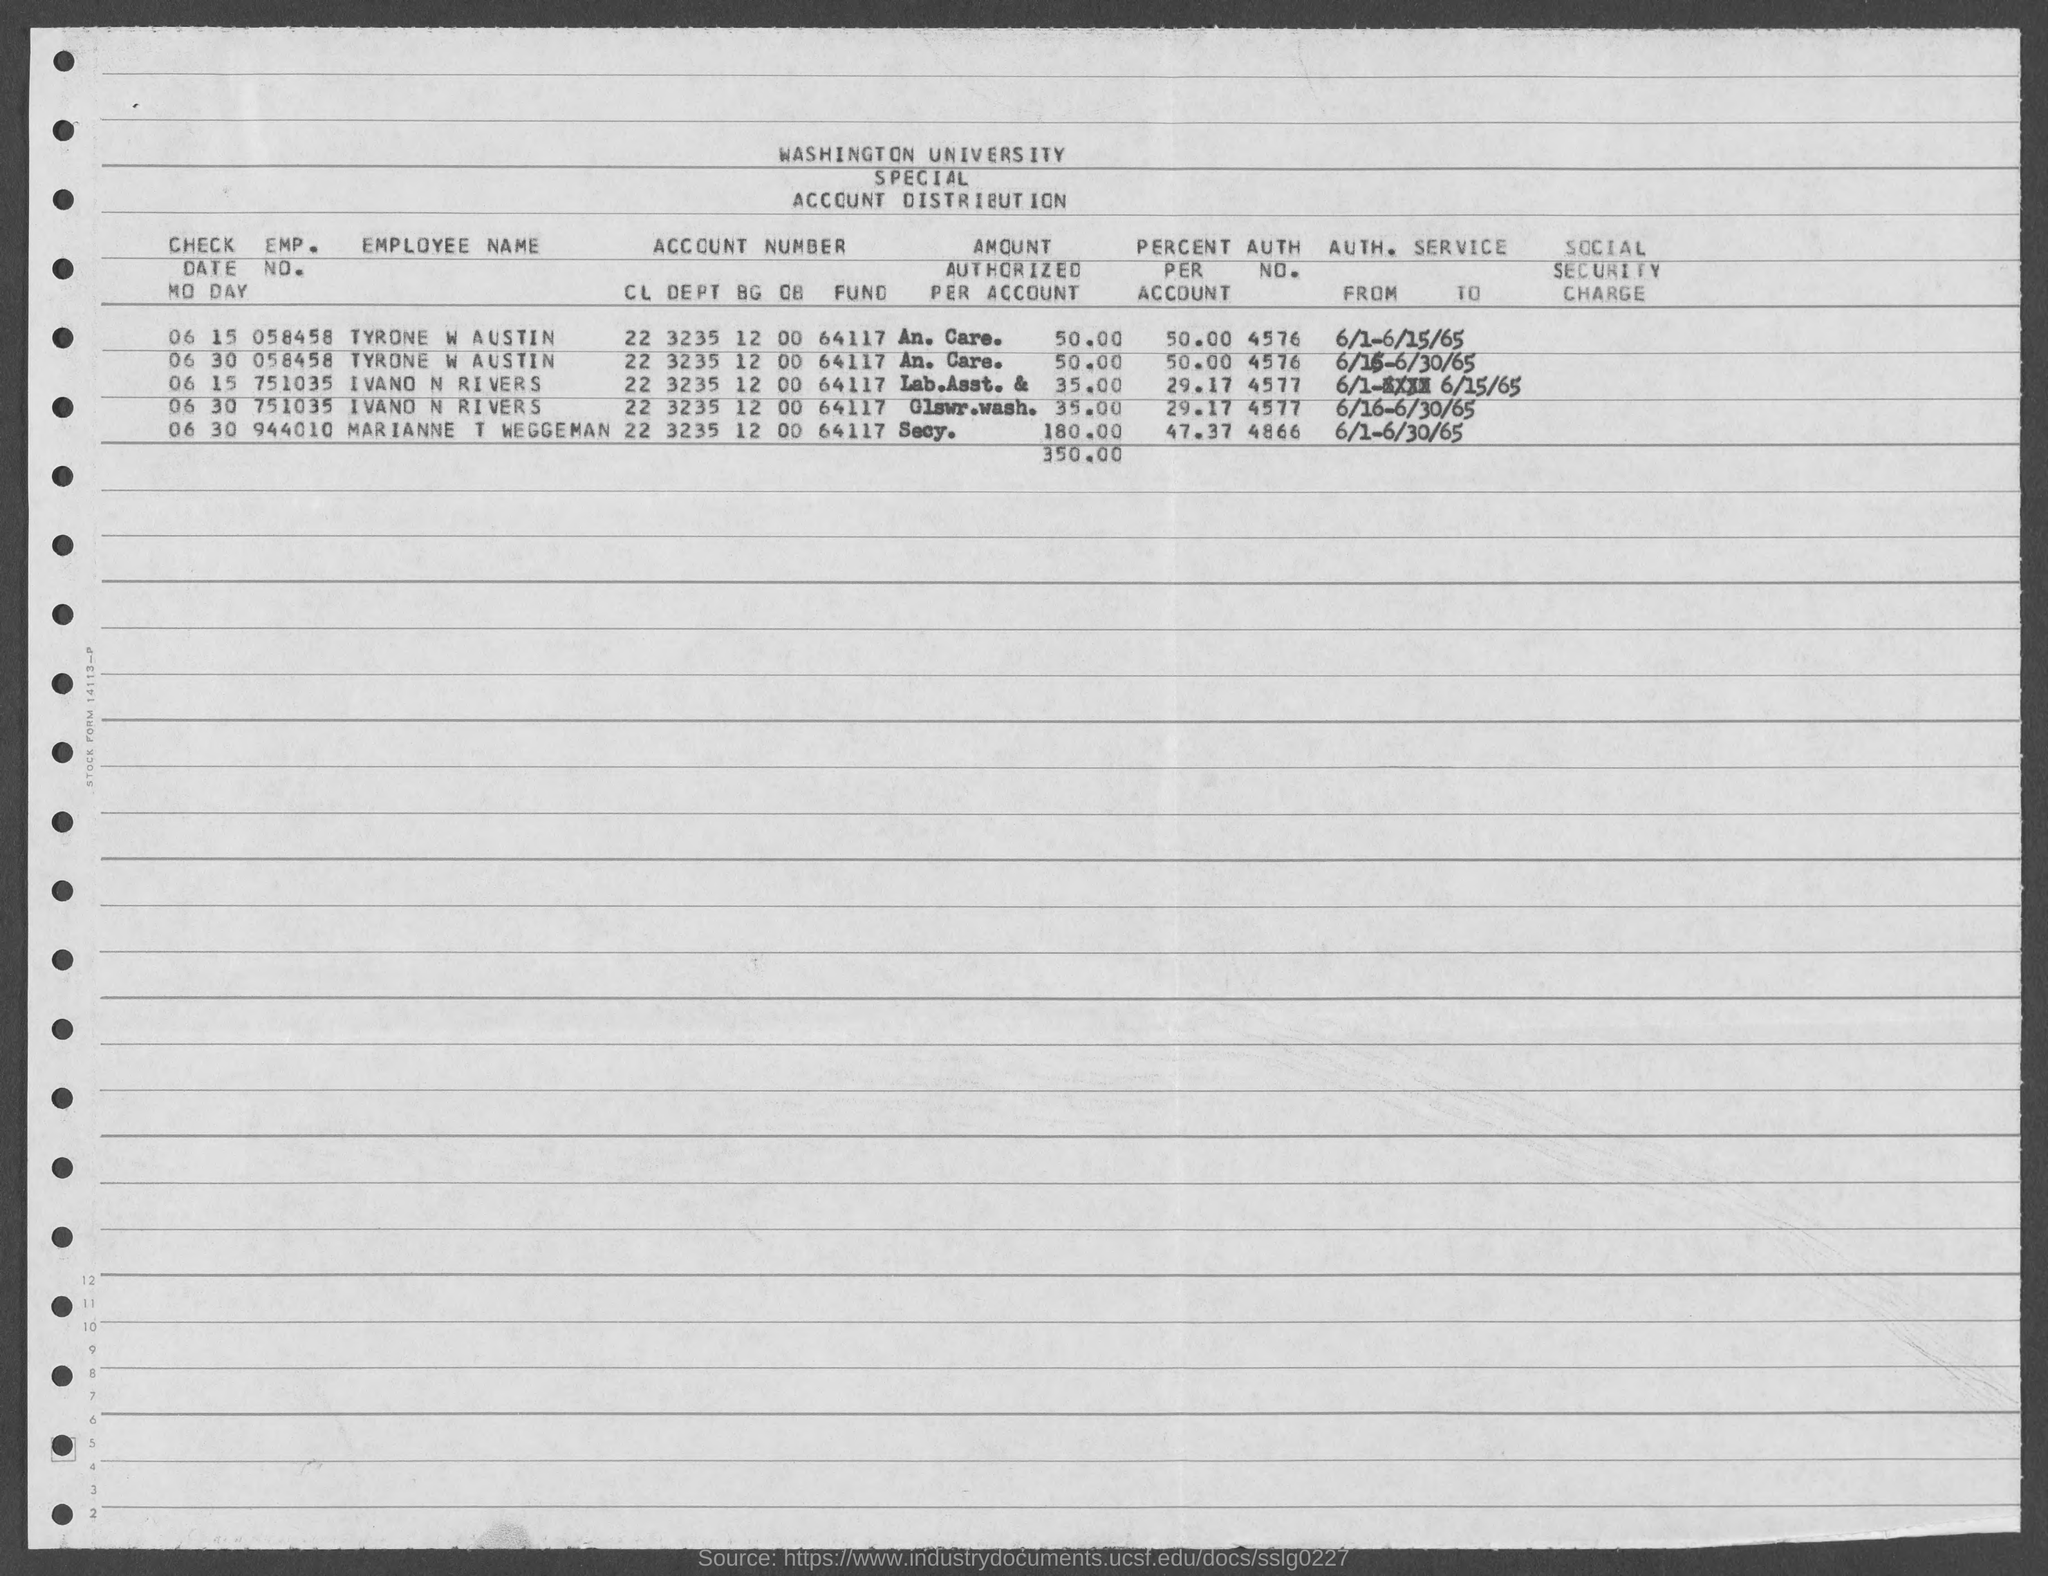Specify some key components in this picture. The AUTH. NO. of IVANO N RIVERS mentioned in the document is 4577. The percent per account of TYRONE W AUSTIN is 50.00. The AUTH. NO. of TYRONE W AUSTIN as listed in the document is 4576. 